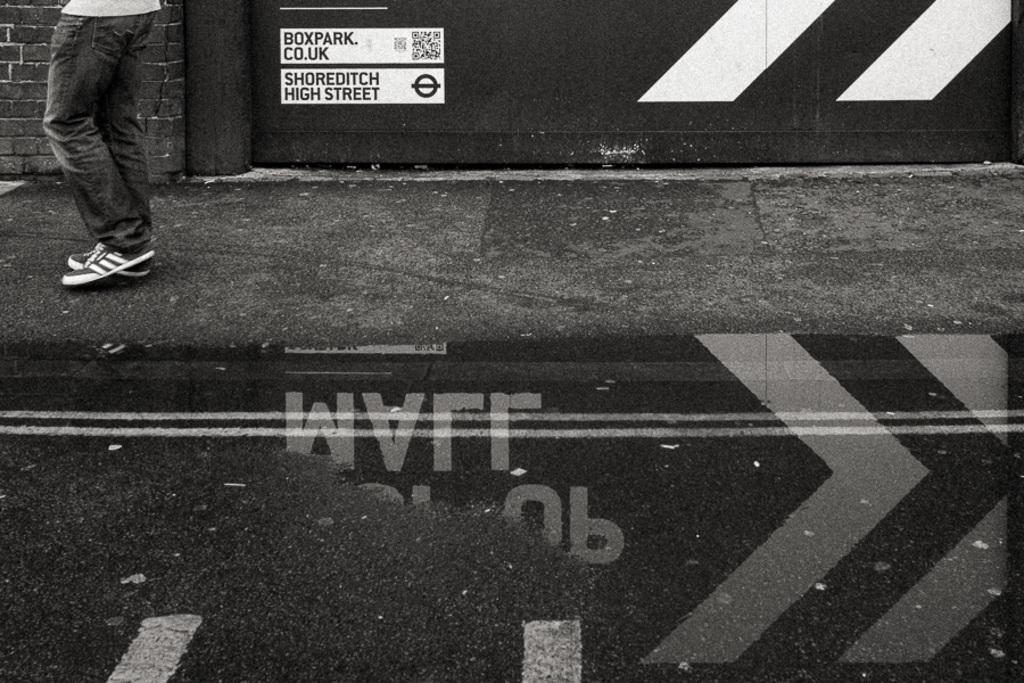What is in the foreground of the image? There is a road and water in the foreground of the image. Can you describe the person in the image? There is a person at the top left of the image. What is behind the person in the image? There is a wall behind the person. How many goldfish are swimming in the water in the image? There are no goldfish visible in the image; it only shows a road and water in the foreground. What type of body is present in the image? There is no specific body mentioned or visible in the image; it only features a person, a road, water, and a wall. 